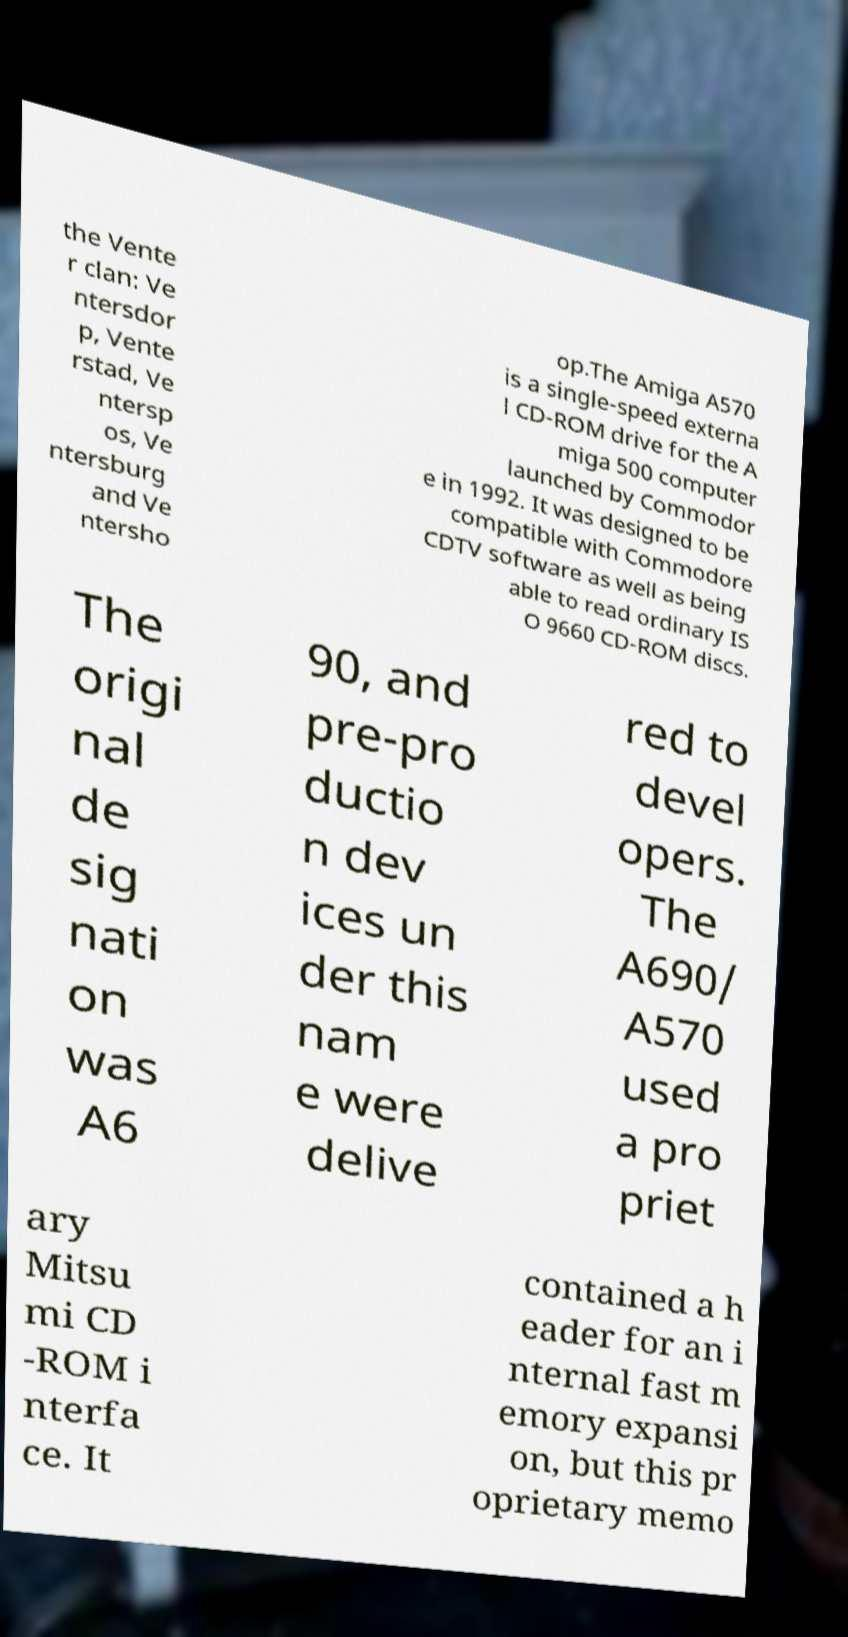Could you extract and type out the text from this image? the Vente r clan: Ve ntersdor p, Vente rstad, Ve ntersp os, Ve ntersburg and Ve ntersho op.The Amiga A570 is a single-speed externa l CD-ROM drive for the A miga 500 computer launched by Commodor e in 1992. It was designed to be compatible with Commodore CDTV software as well as being able to read ordinary IS O 9660 CD-ROM discs. The origi nal de sig nati on was A6 90, and pre-pro ductio n dev ices un der this nam e were delive red to devel opers. The A690/ A570 used a pro priet ary Mitsu mi CD -ROM i nterfa ce. It contained a h eader for an i nternal fast m emory expansi on, but this pr oprietary memo 